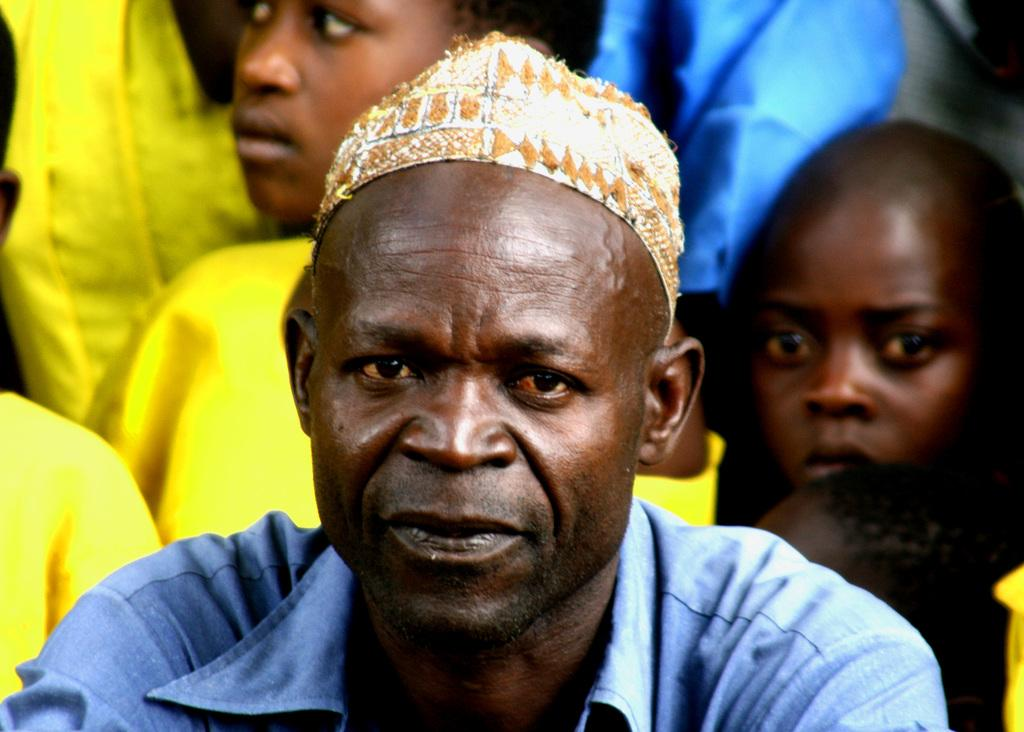Who is present in the image? There is a man in the image. What is the man wearing? The man is wearing a blue color shirt. What accessory is the man wearing on his head? The man has a cap on his head. What is the man looking at? The man is looking at a picture. What colors are the dresses of the people in the background? The people in the background are wearing yellow and blue color dresses. What type of stew is being served in the hole in the image? There is no hole or stew present in the image. 